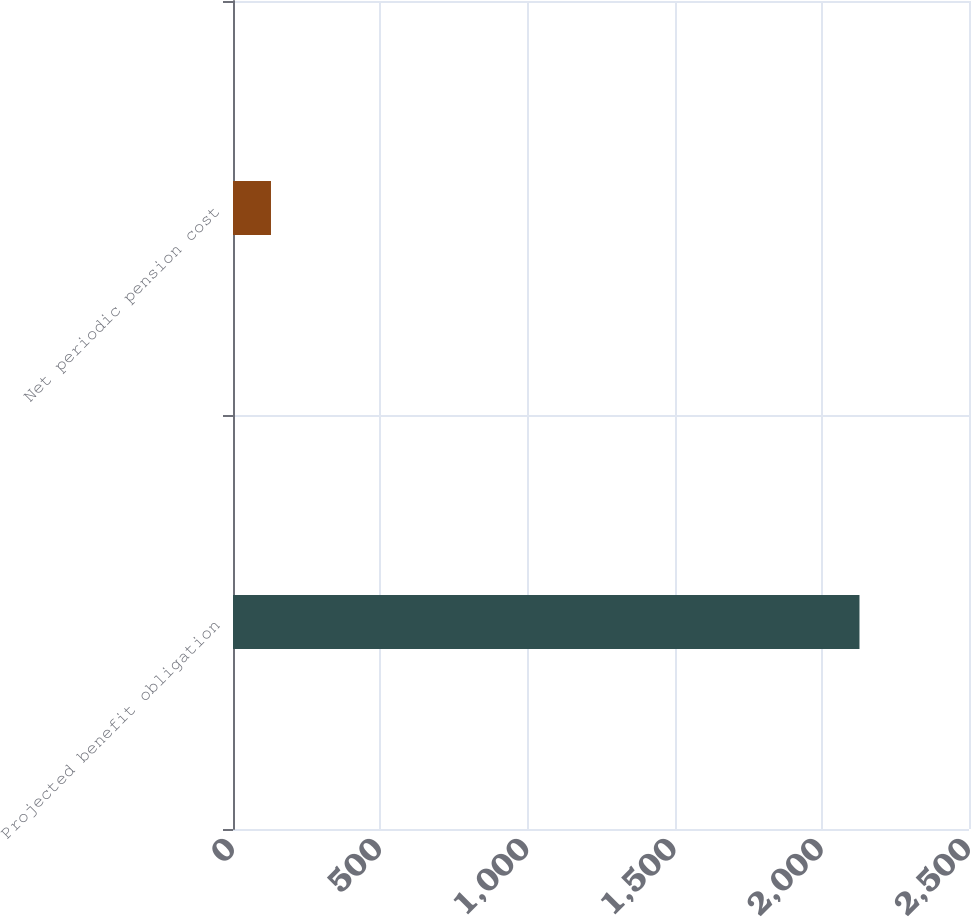Convert chart to OTSL. <chart><loc_0><loc_0><loc_500><loc_500><bar_chart><fcel>Projected benefit obligation<fcel>Net periodic pension cost<nl><fcel>2128<fcel>129<nl></chart> 